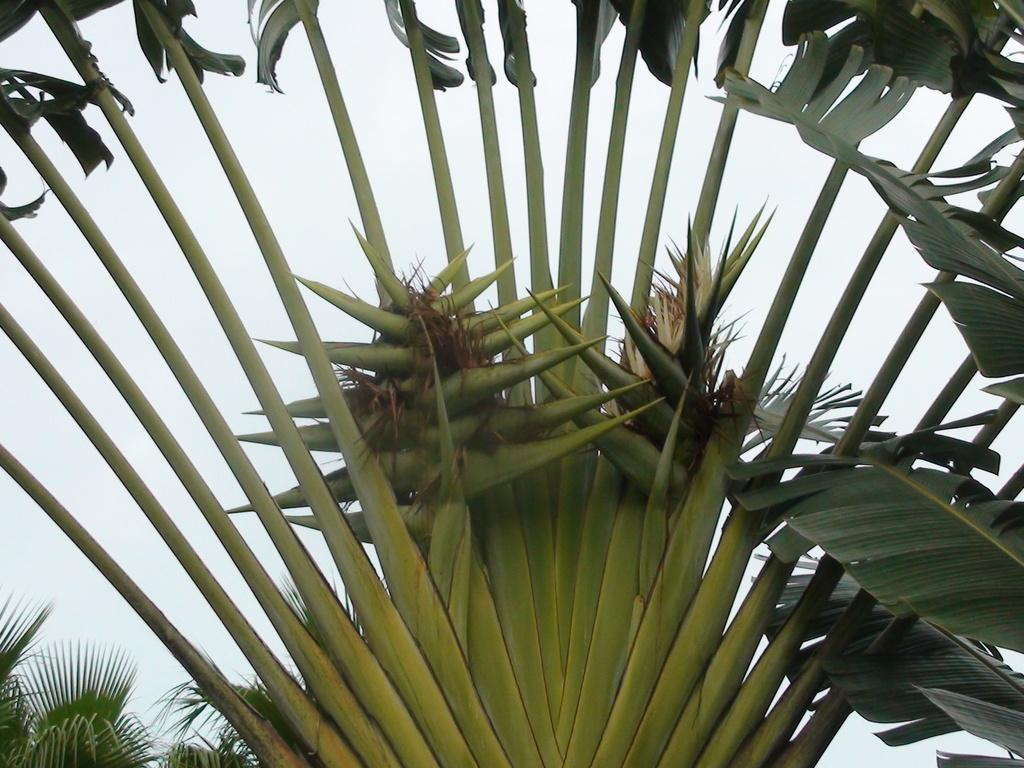What type of vegetation is visible in the image? There are trees in the image. What part of the trees can be seen in the image? There are leaves in the image. What is visible in the background of the image? The sky is visible in the background of the image. What type of veil is draped over the knee of the person in the image? There is no person present in the image, and therefore no veil or knee can be observed. 